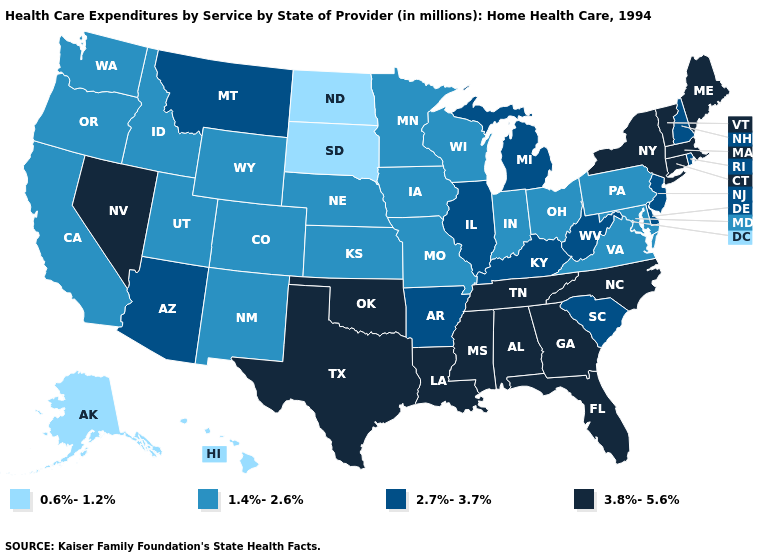What is the lowest value in states that border Illinois?
Answer briefly. 1.4%-2.6%. What is the value of California?
Concise answer only. 1.4%-2.6%. Does Alaska have a lower value than Vermont?
Give a very brief answer. Yes. Is the legend a continuous bar?
Answer briefly. No. What is the value of Tennessee?
Concise answer only. 3.8%-5.6%. What is the highest value in the USA?
Short answer required. 3.8%-5.6%. Name the states that have a value in the range 3.8%-5.6%?
Write a very short answer. Alabama, Connecticut, Florida, Georgia, Louisiana, Maine, Massachusetts, Mississippi, Nevada, New York, North Carolina, Oklahoma, Tennessee, Texas, Vermont. Name the states that have a value in the range 1.4%-2.6%?
Be succinct. California, Colorado, Idaho, Indiana, Iowa, Kansas, Maryland, Minnesota, Missouri, Nebraska, New Mexico, Ohio, Oregon, Pennsylvania, Utah, Virginia, Washington, Wisconsin, Wyoming. What is the value of Mississippi?
Be succinct. 3.8%-5.6%. What is the value of South Dakota?
Concise answer only. 0.6%-1.2%. Among the states that border North Carolina , which have the highest value?
Concise answer only. Georgia, Tennessee. Among the states that border New Hampshire , which have the lowest value?
Be succinct. Maine, Massachusetts, Vermont. What is the value of Delaware?
Keep it brief. 2.7%-3.7%. What is the lowest value in the South?
Write a very short answer. 1.4%-2.6%. What is the value of Wyoming?
Write a very short answer. 1.4%-2.6%. 